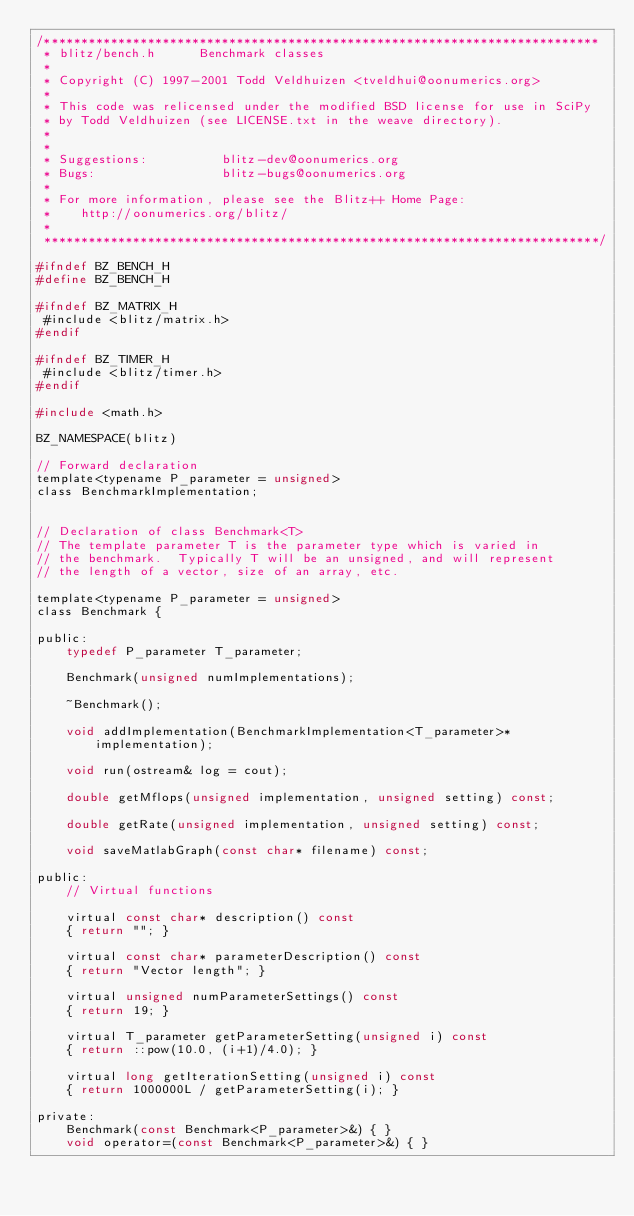<code> <loc_0><loc_0><loc_500><loc_500><_C_>/***************************************************************************
 * blitz/bench.h      Benchmark classes
 *
 * Copyright (C) 1997-2001 Todd Veldhuizen <tveldhui@oonumerics.org>
 *
 * This code was relicensed under the modified BSD license for use in SciPy
 * by Todd Veldhuizen (see LICENSE.txt in the weave directory).
 *
 *
 * Suggestions:          blitz-dev@oonumerics.org
 * Bugs:                 blitz-bugs@oonumerics.org
 *
 * For more information, please see the Blitz++ Home Page:
 *    http://oonumerics.org/blitz/
 *
 ***************************************************************************/

#ifndef BZ_BENCH_H
#define BZ_BENCH_H

#ifndef BZ_MATRIX_H
 #include <blitz/matrix.h>
#endif

#ifndef BZ_TIMER_H
 #include <blitz/timer.h>
#endif

#include <math.h>

BZ_NAMESPACE(blitz)

// Forward declaration
template<typename P_parameter = unsigned>
class BenchmarkImplementation;


// Declaration of class Benchmark<T>
// The template parameter T is the parameter type which is varied in
// the benchmark.  Typically T will be an unsigned, and will represent
// the length of a vector, size of an array, etc.

template<typename P_parameter = unsigned>
class Benchmark {

public:
    typedef P_parameter T_parameter;

    Benchmark(unsigned numImplementations);

    ~Benchmark();

    void addImplementation(BenchmarkImplementation<T_parameter>* 
        implementation);

    void run(ostream& log = cout);

    double getMflops(unsigned implementation, unsigned setting) const;

    double getRate(unsigned implementation, unsigned setting) const;

    void saveMatlabGraph(const char* filename) const;

public:
    // Virtual functions

    virtual const char* description() const
    { return ""; }

    virtual const char* parameterDescription() const
    { return "Vector length"; }

    virtual unsigned numParameterSettings() const
    { return 19; }

    virtual T_parameter getParameterSetting(unsigned i) const
    { return ::pow(10.0, (i+1)/4.0); }

    virtual long getIterationSetting(unsigned i) const
    { return 1000000L / getParameterSetting(i); }

private:
    Benchmark(const Benchmark<P_parameter>&) { }
    void operator=(const Benchmark<P_parameter>&) { }
</code> 